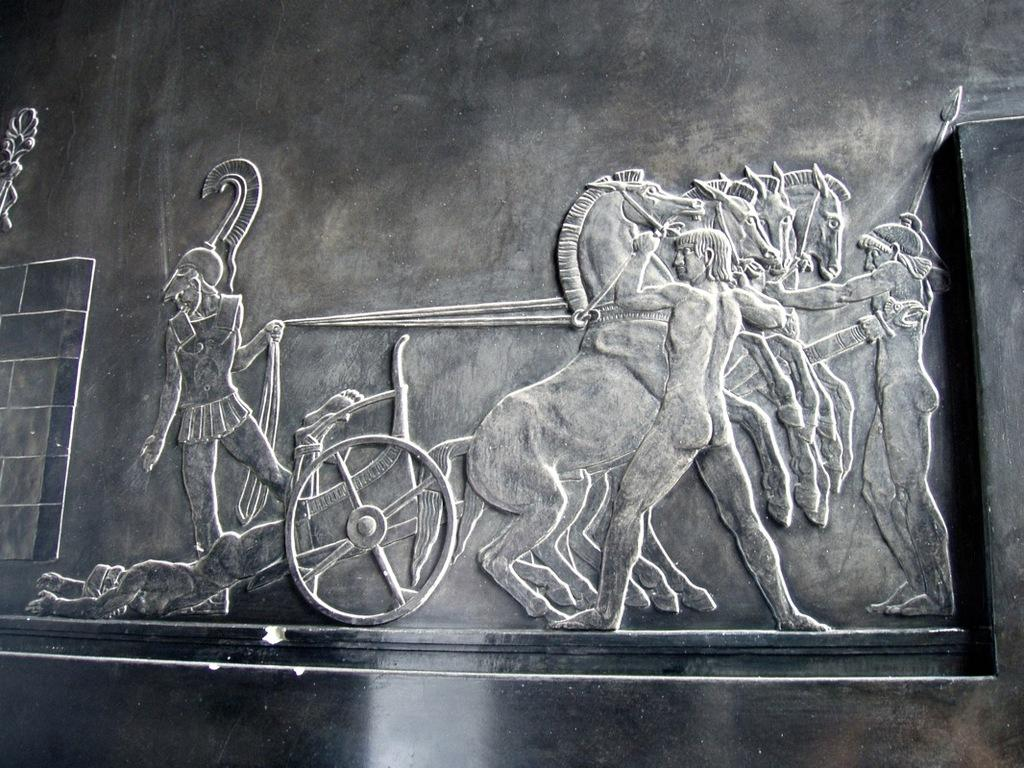What is depicted in the carving in the image? There is a carving of a person riding a horse cart in the image. Who else is present in the image besides the person on the horse cart? There are two men standing on the right side of the image. How are the two men positioned in relation to the horses? The two men are opposing the horses. How many deer can be seen interacting with the mice in the image? There are no deer or mice present in the image; it features a carving of a person riding a horse cart and two men standing nearby. 